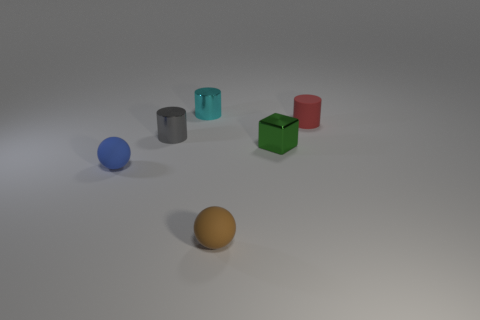Subtract all metal cylinders. How many cylinders are left? 1 Add 2 big matte cylinders. How many objects exist? 8 Subtract all red cylinders. How many cylinders are left? 2 Subtract 1 cylinders. How many cylinders are left? 2 Subtract all green balls. Subtract all purple cubes. How many balls are left? 2 Subtract all gray objects. Subtract all red matte cylinders. How many objects are left? 4 Add 5 tiny cyan things. How many tiny cyan things are left? 6 Add 5 big purple metal objects. How many big purple metal objects exist? 5 Subtract 1 cyan cylinders. How many objects are left? 5 Subtract all balls. How many objects are left? 4 